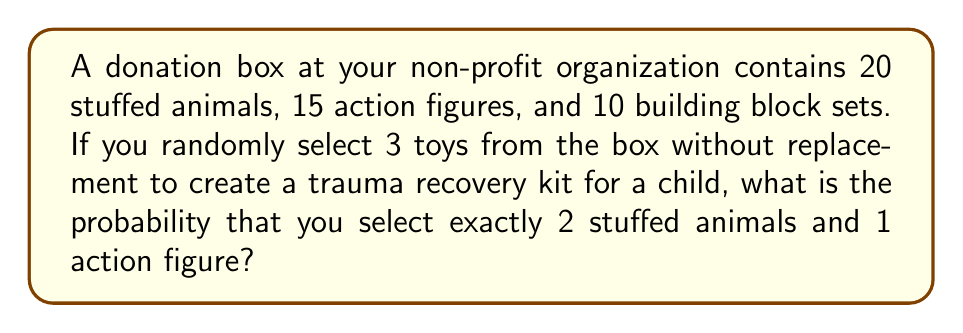Can you answer this question? Let's approach this step-by-step:

1) First, we need to calculate the total number of ways to select 3 toys from the box. This can be done using the combination formula:

   $$\binom{45}{3} = \frac{45!}{3!(45-3)!} = 14190$$

2) Now, we need to calculate the number of ways to select 2 stuffed animals and 1 action figure:

   a) Select 2 stuffed animals out of 20: $\binom{20}{2} = 190$
   b) Select 1 action figure out of 15: $\binom{15}{1} = 15$

3) The total number of favorable outcomes is the product of these:

   $$190 \times 15 = 2850$$

4) The probability is then the number of favorable outcomes divided by the total number of possible outcomes:

   $$P(\text{2 stuffed animals and 1 action figure}) = \frac{2850}{14190}$$

5) Simplifying this fraction:

   $$\frac{2850}{14190} = \frac{19}{94} \approx 0.2021$$

Therefore, the probability of selecting exactly 2 stuffed animals and 1 action figure is $\frac{19}{94}$ or approximately 20.21%.
Answer: $\frac{19}{94}$ 